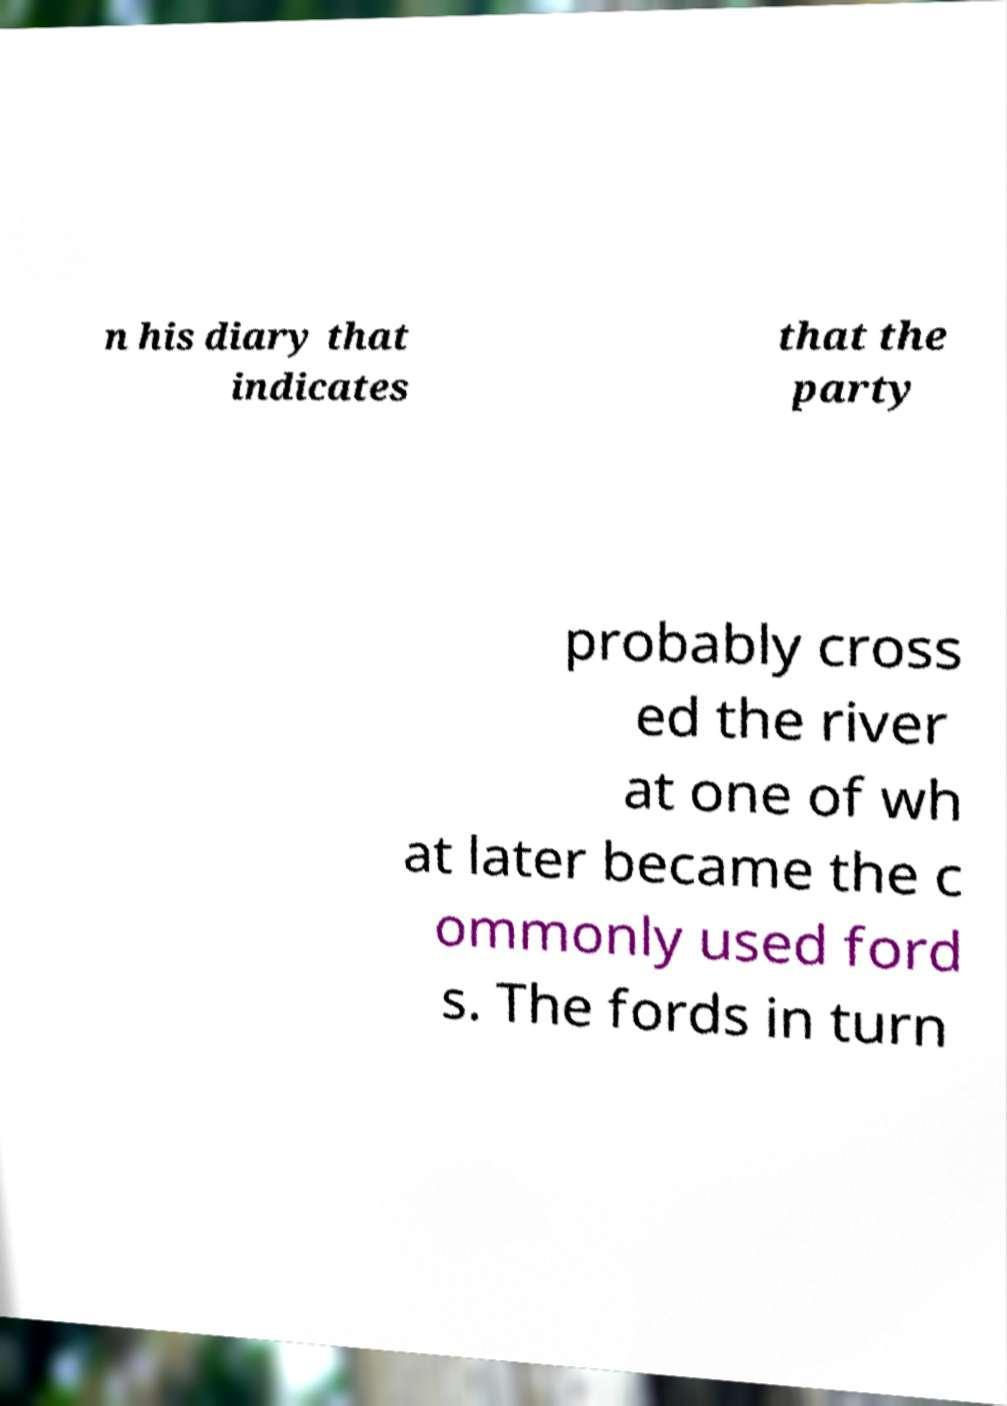Can you read and provide the text displayed in the image?This photo seems to have some interesting text. Can you extract and type it out for me? n his diary that indicates that the party probably cross ed the river at one of wh at later became the c ommonly used ford s. The fords in turn 